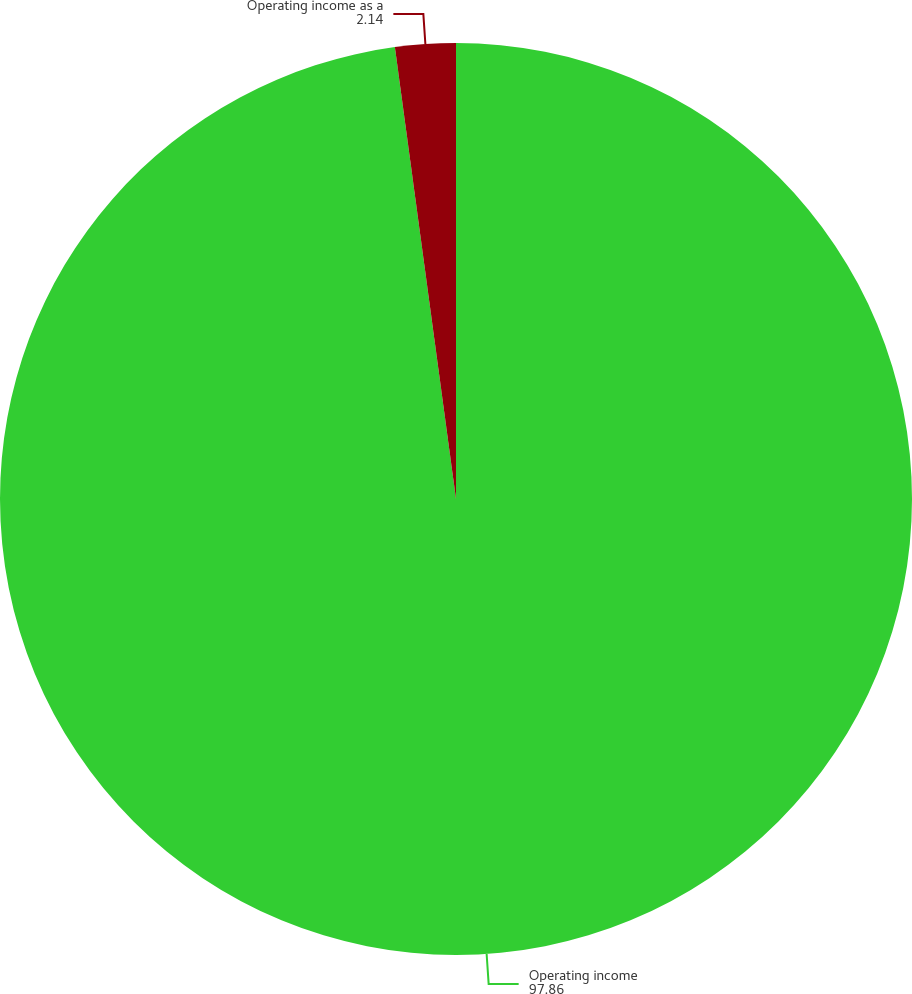Convert chart. <chart><loc_0><loc_0><loc_500><loc_500><pie_chart><fcel>Operating income<fcel>Operating income as a<nl><fcel>97.86%<fcel>2.14%<nl></chart> 